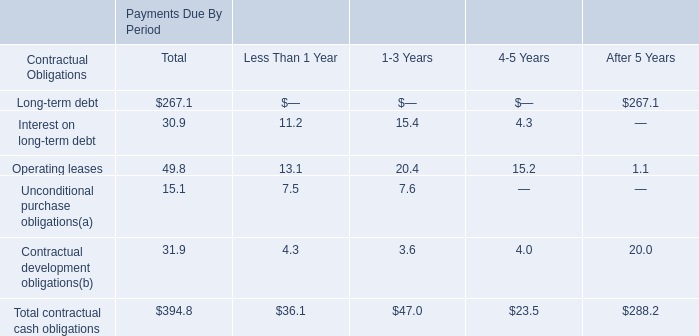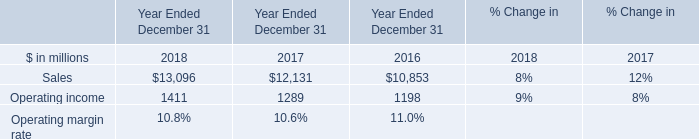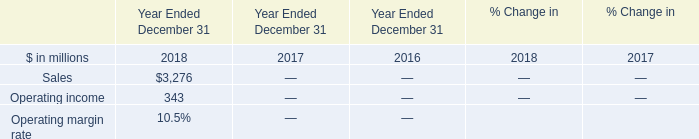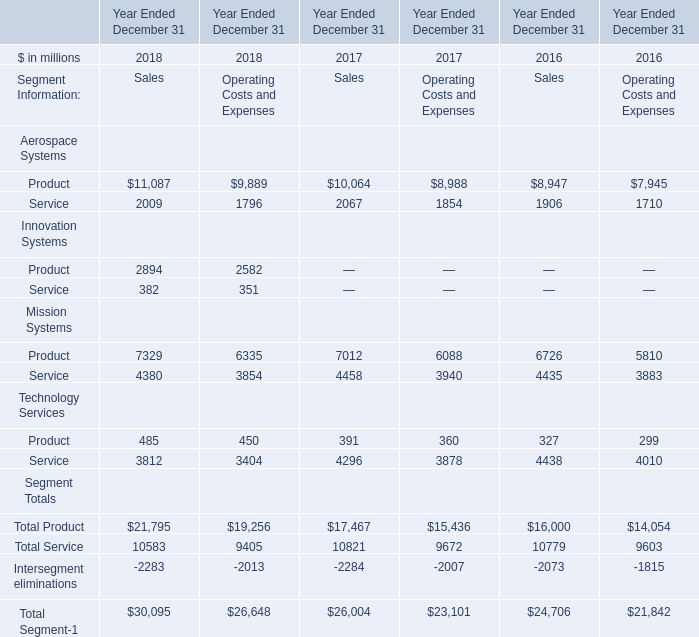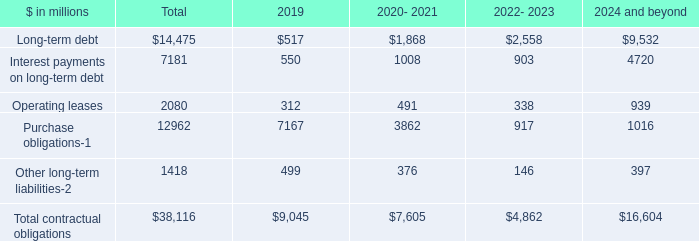What is the sum of Purchase obligations of 2024 and beyond, and Service Mission Systems of Year Ended December 31 2016 Sales ? 
Computations: (1016.0 + 4435.0)
Answer: 5451.0. 